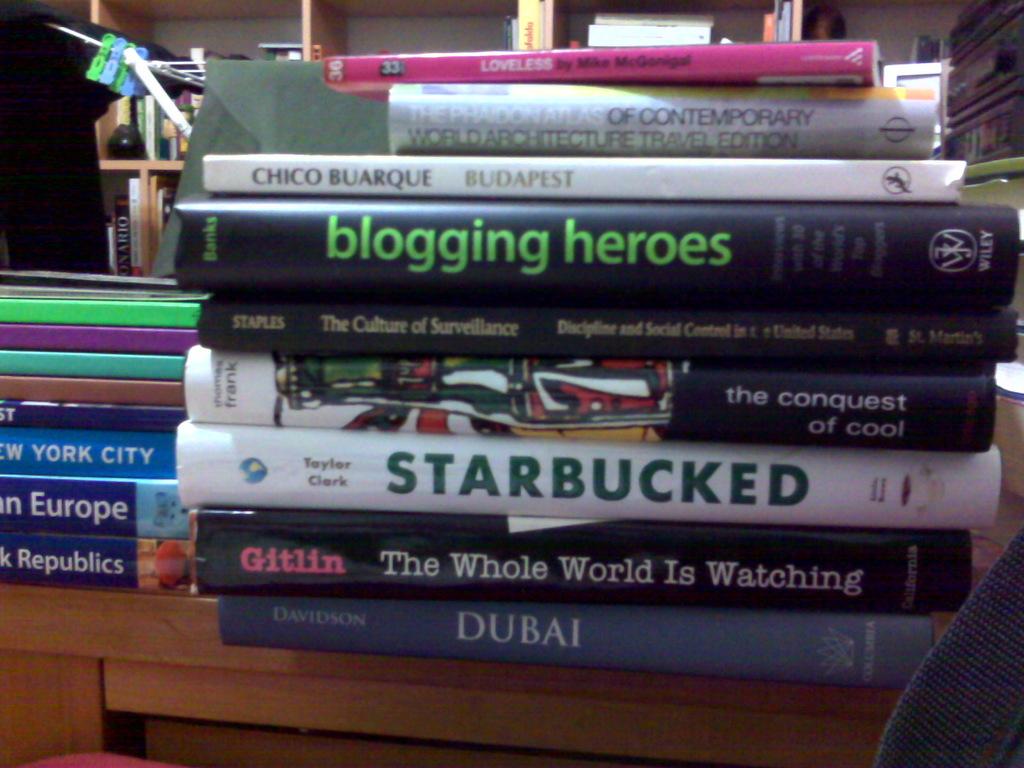Who wrote the book starbucked?
Your response must be concise. Taylor clark. 